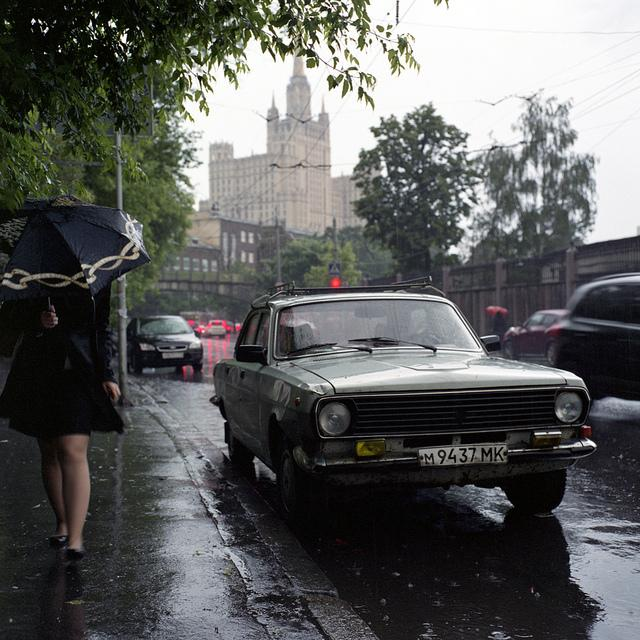What is the danger faced by the woman on the left? Please explain your reasoning. getting splashed. The woman is near water puddles. 